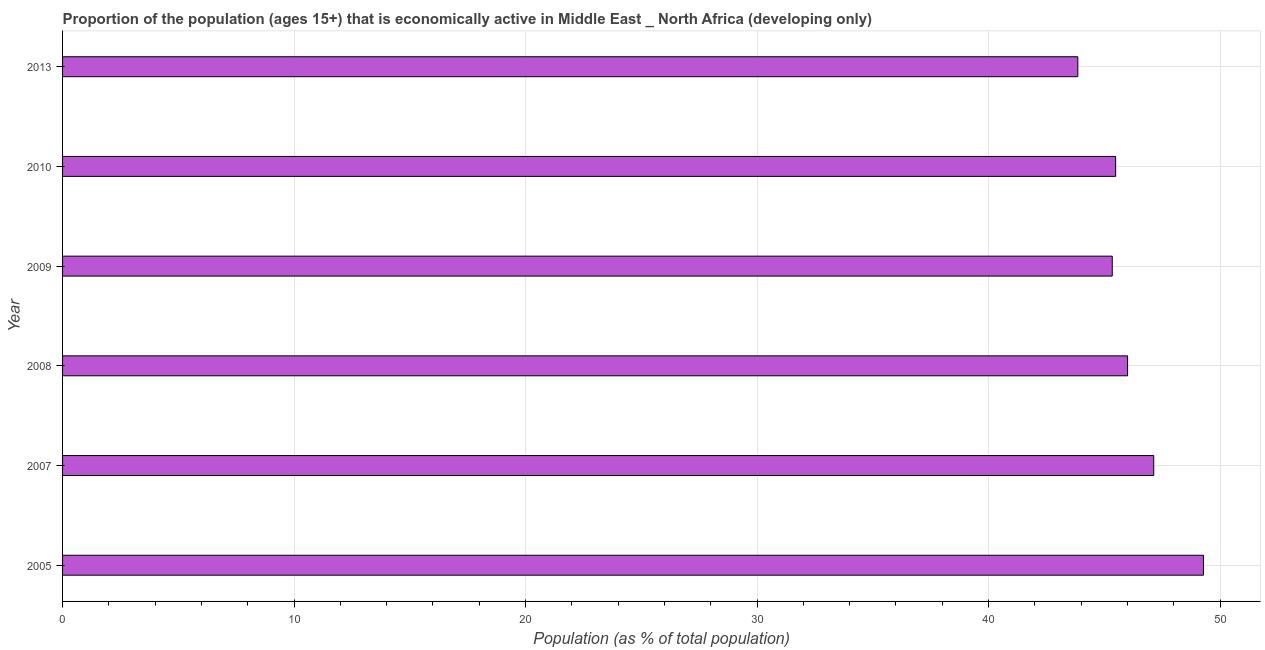Does the graph contain any zero values?
Offer a very short reply. No. What is the title of the graph?
Keep it short and to the point. Proportion of the population (ages 15+) that is economically active in Middle East _ North Africa (developing only). What is the label or title of the X-axis?
Your answer should be compact. Population (as % of total population). What is the percentage of economically active population in 2008?
Your response must be concise. 46.01. Across all years, what is the maximum percentage of economically active population?
Give a very brief answer. 49.28. Across all years, what is the minimum percentage of economically active population?
Your response must be concise. 43.86. In which year was the percentage of economically active population maximum?
Your answer should be very brief. 2005. In which year was the percentage of economically active population minimum?
Offer a terse response. 2013. What is the sum of the percentage of economically active population?
Keep it short and to the point. 277.12. What is the difference between the percentage of economically active population in 2009 and 2010?
Provide a short and direct response. -0.15. What is the average percentage of economically active population per year?
Your response must be concise. 46.19. What is the median percentage of economically active population?
Make the answer very short. 45.75. Do a majority of the years between 2010 and 2013 (inclusive) have percentage of economically active population greater than 18 %?
Provide a short and direct response. Yes. What is the ratio of the percentage of economically active population in 2005 to that in 2013?
Make the answer very short. 1.12. Is the percentage of economically active population in 2007 less than that in 2009?
Offer a terse response. No. Is the difference between the percentage of economically active population in 2008 and 2013 greater than the difference between any two years?
Your answer should be very brief. No. What is the difference between the highest and the second highest percentage of economically active population?
Provide a succinct answer. 2.15. What is the difference between the highest and the lowest percentage of economically active population?
Ensure brevity in your answer.  5.43. Are all the bars in the graph horizontal?
Offer a very short reply. Yes. What is the difference between two consecutive major ticks on the X-axis?
Ensure brevity in your answer.  10. What is the Population (as % of total population) in 2005?
Give a very brief answer. 49.28. What is the Population (as % of total population) of 2007?
Your response must be concise. 47.14. What is the Population (as % of total population) in 2008?
Give a very brief answer. 46.01. What is the Population (as % of total population) of 2009?
Ensure brevity in your answer.  45.34. What is the Population (as % of total population) of 2010?
Offer a terse response. 45.49. What is the Population (as % of total population) in 2013?
Make the answer very short. 43.86. What is the difference between the Population (as % of total population) in 2005 and 2007?
Provide a short and direct response. 2.15. What is the difference between the Population (as % of total population) in 2005 and 2008?
Provide a succinct answer. 3.28. What is the difference between the Population (as % of total population) in 2005 and 2009?
Your answer should be compact. 3.94. What is the difference between the Population (as % of total population) in 2005 and 2010?
Offer a terse response. 3.79. What is the difference between the Population (as % of total population) in 2005 and 2013?
Give a very brief answer. 5.43. What is the difference between the Population (as % of total population) in 2007 and 2008?
Ensure brevity in your answer.  1.13. What is the difference between the Population (as % of total population) in 2007 and 2009?
Keep it short and to the point. 1.79. What is the difference between the Population (as % of total population) in 2007 and 2010?
Provide a succinct answer. 1.65. What is the difference between the Population (as % of total population) in 2007 and 2013?
Keep it short and to the point. 3.28. What is the difference between the Population (as % of total population) in 2008 and 2009?
Your response must be concise. 0.66. What is the difference between the Population (as % of total population) in 2008 and 2010?
Offer a very short reply. 0.52. What is the difference between the Population (as % of total population) in 2008 and 2013?
Offer a very short reply. 2.15. What is the difference between the Population (as % of total population) in 2009 and 2010?
Give a very brief answer. -0.15. What is the difference between the Population (as % of total population) in 2009 and 2013?
Provide a succinct answer. 1.49. What is the difference between the Population (as % of total population) in 2010 and 2013?
Your answer should be compact. 1.63. What is the ratio of the Population (as % of total population) in 2005 to that in 2007?
Provide a short and direct response. 1.05. What is the ratio of the Population (as % of total population) in 2005 to that in 2008?
Provide a succinct answer. 1.07. What is the ratio of the Population (as % of total population) in 2005 to that in 2009?
Give a very brief answer. 1.09. What is the ratio of the Population (as % of total population) in 2005 to that in 2010?
Ensure brevity in your answer.  1.08. What is the ratio of the Population (as % of total population) in 2005 to that in 2013?
Provide a short and direct response. 1.12. What is the ratio of the Population (as % of total population) in 2007 to that in 2010?
Provide a succinct answer. 1.04. What is the ratio of the Population (as % of total population) in 2007 to that in 2013?
Provide a succinct answer. 1.07. What is the ratio of the Population (as % of total population) in 2008 to that in 2009?
Your response must be concise. 1.01. What is the ratio of the Population (as % of total population) in 2008 to that in 2013?
Provide a succinct answer. 1.05. What is the ratio of the Population (as % of total population) in 2009 to that in 2010?
Provide a succinct answer. 1. What is the ratio of the Population (as % of total population) in 2009 to that in 2013?
Your response must be concise. 1.03. 